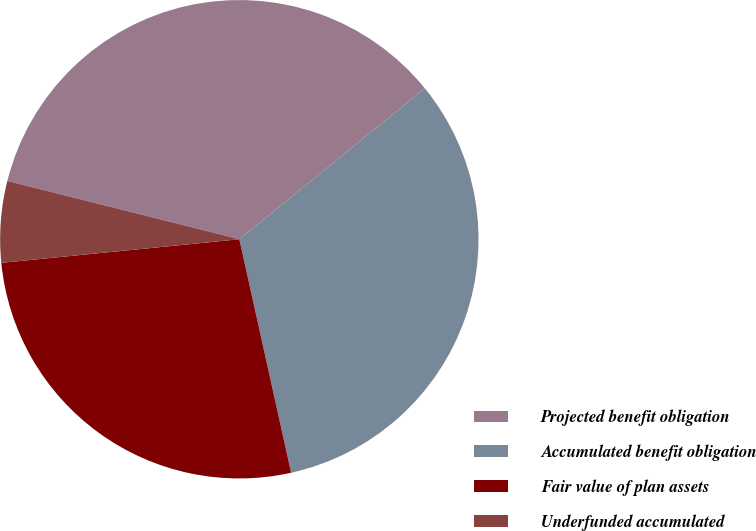Convert chart. <chart><loc_0><loc_0><loc_500><loc_500><pie_chart><fcel>Projected benefit obligation<fcel>Accumulated benefit obligation<fcel>Fair value of plan assets<fcel>Underfunded accumulated<nl><fcel>35.21%<fcel>32.39%<fcel>26.9%<fcel>5.49%<nl></chart> 